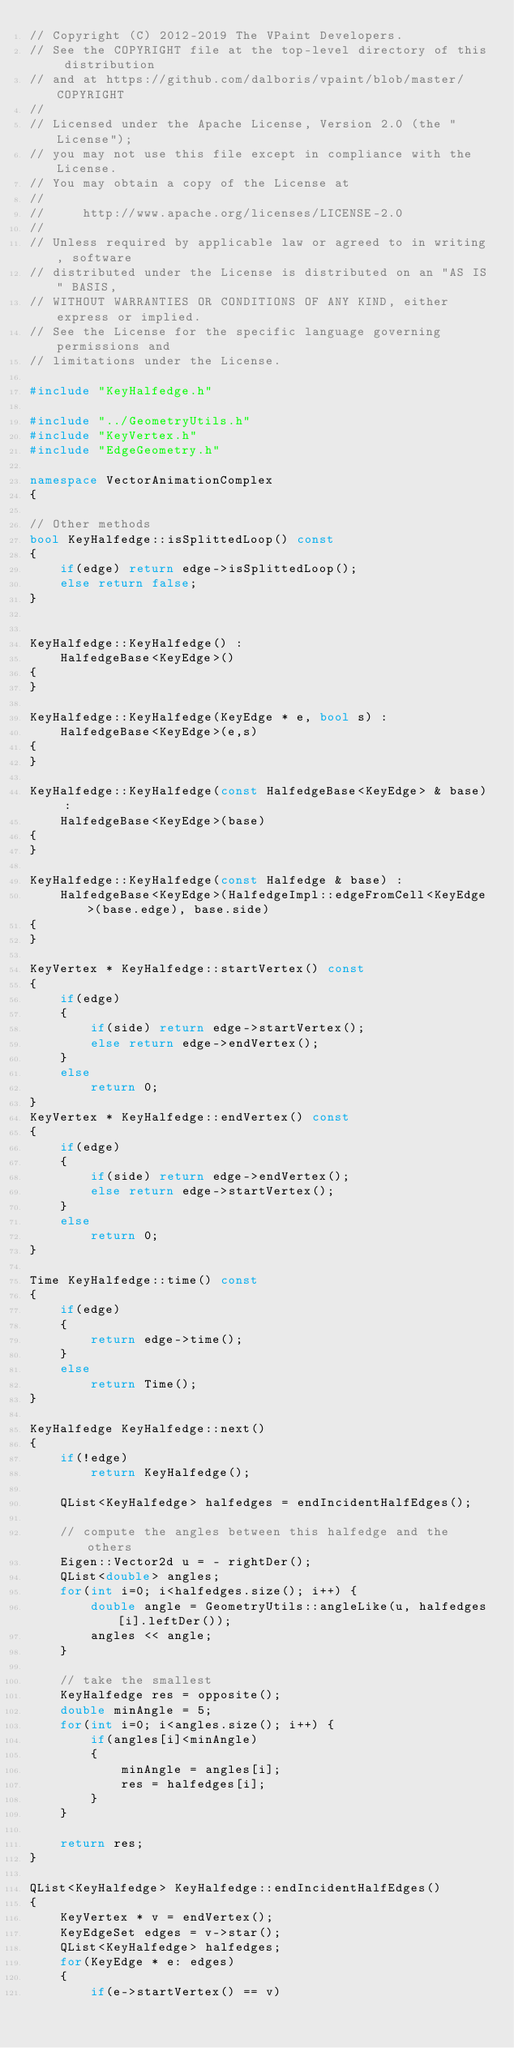<code> <loc_0><loc_0><loc_500><loc_500><_C++_>// Copyright (C) 2012-2019 The VPaint Developers.
// See the COPYRIGHT file at the top-level directory of this distribution
// and at https://github.com/dalboris/vpaint/blob/master/COPYRIGHT
//
// Licensed under the Apache License, Version 2.0 (the "License");
// you may not use this file except in compliance with the License.
// You may obtain a copy of the License at
//
//     http://www.apache.org/licenses/LICENSE-2.0
//
// Unless required by applicable law or agreed to in writing, software
// distributed under the License is distributed on an "AS IS" BASIS,
// WITHOUT WARRANTIES OR CONDITIONS OF ANY KIND, either express or implied.
// See the License for the specific language governing permissions and
// limitations under the License.

#include "KeyHalfedge.h"

#include "../GeometryUtils.h"
#include "KeyVertex.h"
#include "EdgeGeometry.h"

namespace VectorAnimationComplex
{

// Other methods
bool KeyHalfedge::isSplittedLoop() const
{
    if(edge) return edge->isSplittedLoop();
    else return false;
}


KeyHalfedge::KeyHalfedge() :
    HalfedgeBase<KeyEdge>()
{
}

KeyHalfedge::KeyHalfedge(KeyEdge * e, bool s) :
    HalfedgeBase<KeyEdge>(e,s)
{
}

KeyHalfedge::KeyHalfedge(const HalfedgeBase<KeyEdge> & base) :
    HalfedgeBase<KeyEdge>(base)
{
}

KeyHalfedge::KeyHalfedge(const Halfedge & base) :
    HalfedgeBase<KeyEdge>(HalfedgeImpl::edgeFromCell<KeyEdge>(base.edge), base.side)
{
}

KeyVertex * KeyHalfedge::startVertex() const
{
    if(edge)
    {
        if(side) return edge->startVertex();
        else return edge->endVertex();
    }
    else
        return 0;
}
KeyVertex * KeyHalfedge::endVertex() const
{
    if(edge)
    {
        if(side) return edge->endVertex();
        else return edge->startVertex();
    }
    else
        return 0;
}

Time KeyHalfedge::time() const
{
    if(edge)
    {
        return edge->time();
    }
    else
        return Time();
}

KeyHalfedge KeyHalfedge::next()
{
    if(!edge)
        return KeyHalfedge();

    QList<KeyHalfedge> halfedges = endIncidentHalfEdges();

    // compute the angles between this halfedge and the others
    Eigen::Vector2d u = - rightDer();
    QList<double> angles;
    for(int i=0; i<halfedges.size(); i++) {
        double angle = GeometryUtils::angleLike(u, halfedges[i].leftDer());
        angles << angle;
    }

    // take the smallest
    KeyHalfedge res = opposite();
    double minAngle = 5;
    for(int i=0; i<angles.size(); i++) {
        if(angles[i]<minAngle)
        {
            minAngle = angles[i];
            res = halfedges[i];
        }
    }

    return res;
}

QList<KeyHalfedge> KeyHalfedge::endIncidentHalfEdges()
{
    KeyVertex * v = endVertex();
    KeyEdgeSet edges = v->star();
    QList<KeyHalfedge> halfedges;
    for(KeyEdge * e: edges)
    {
        if(e->startVertex() == v)</code> 